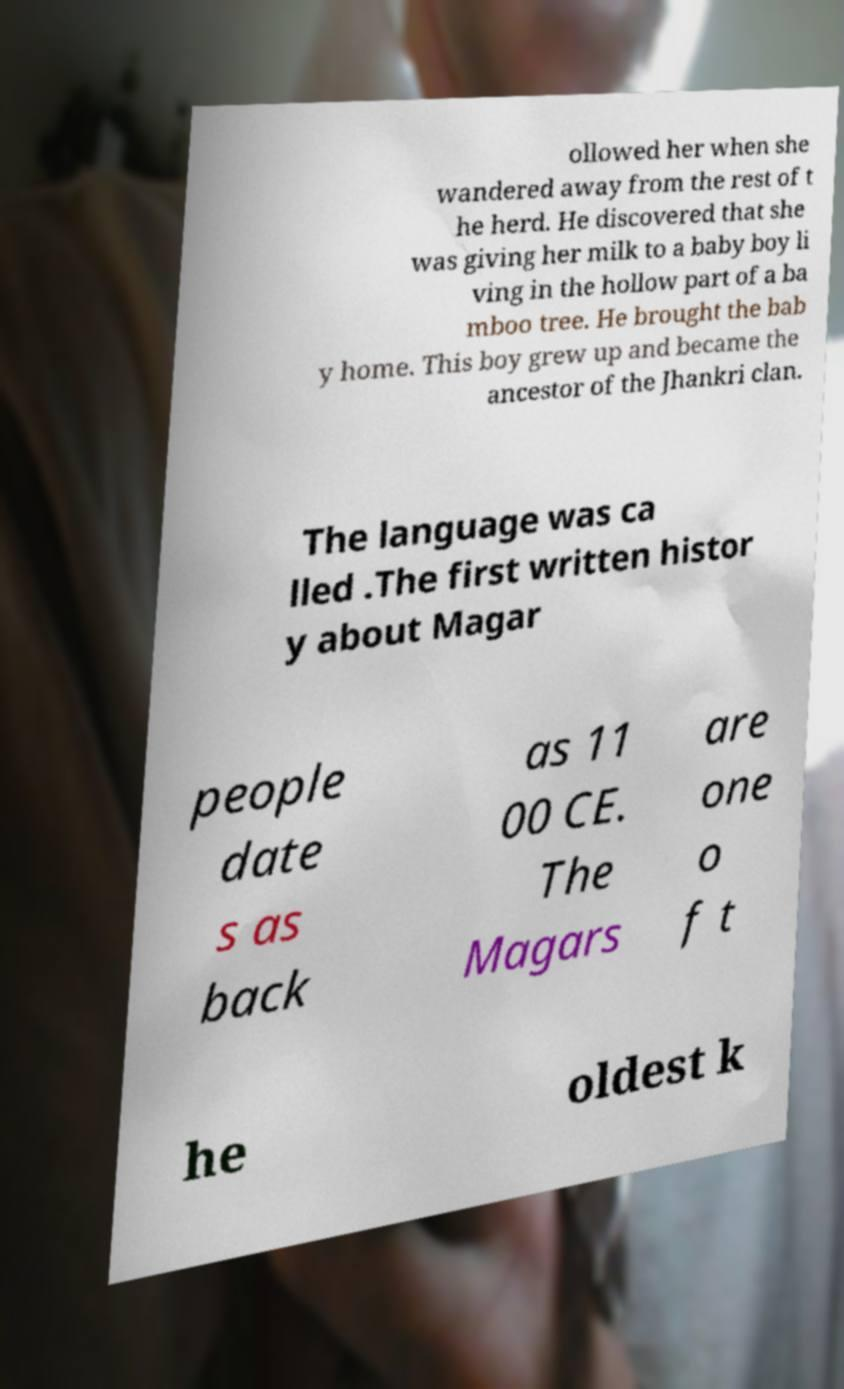For documentation purposes, I need the text within this image transcribed. Could you provide that? ollowed her when she wandered away from the rest of t he herd. He discovered that she was giving her milk to a baby boy li ving in the hollow part of a ba mboo tree. He brought the bab y home. This boy grew up and became the ancestor of the Jhankri clan. The language was ca lled .The first written histor y about Magar people date s as back as 11 00 CE. The Magars are one o f t he oldest k 